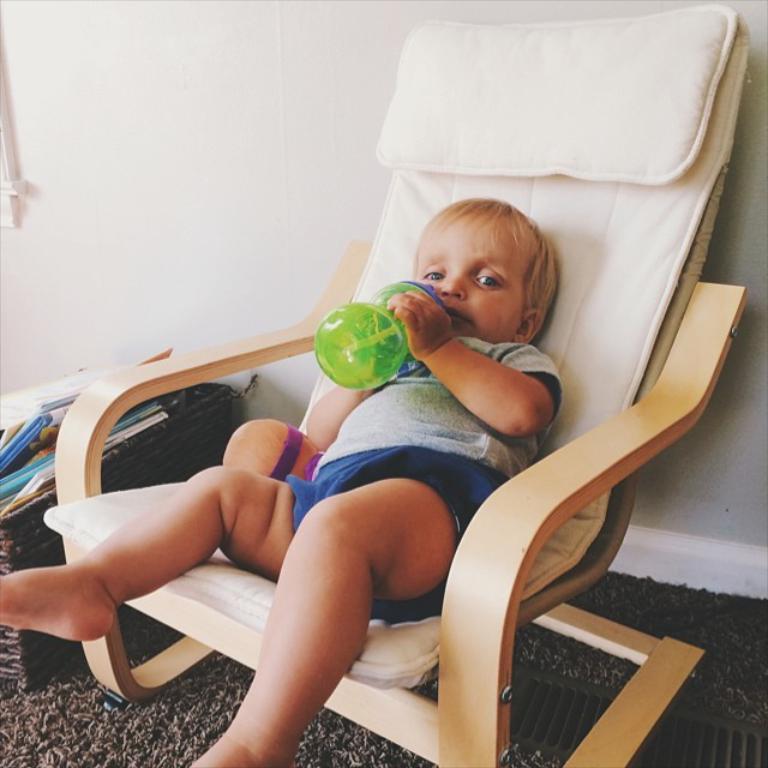Please provide a concise description of this image. In this image there is a kid sitting on the chair and holding sipper in his hand. 